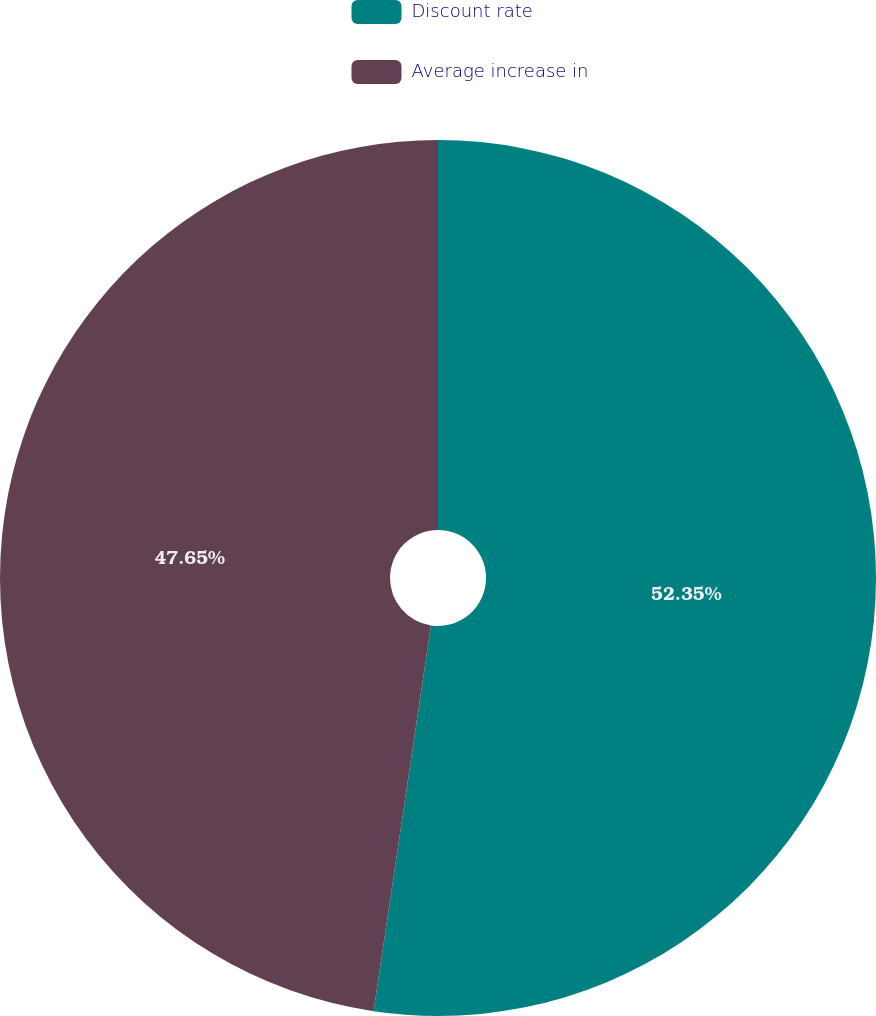<chart> <loc_0><loc_0><loc_500><loc_500><pie_chart><fcel>Discount rate<fcel>Average increase in<nl><fcel>52.35%<fcel>47.65%<nl></chart> 